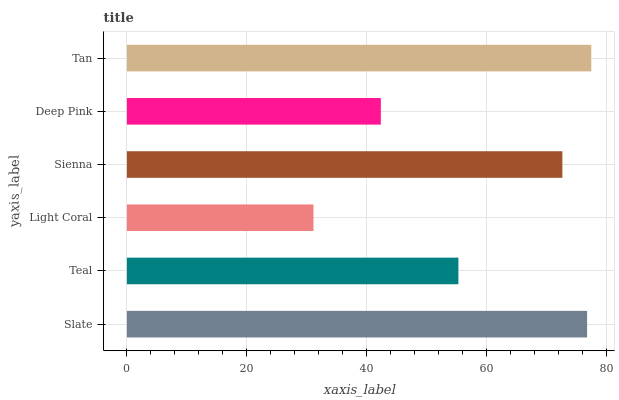Is Light Coral the minimum?
Answer yes or no. Yes. Is Tan the maximum?
Answer yes or no. Yes. Is Teal the minimum?
Answer yes or no. No. Is Teal the maximum?
Answer yes or no. No. Is Slate greater than Teal?
Answer yes or no. Yes. Is Teal less than Slate?
Answer yes or no. Yes. Is Teal greater than Slate?
Answer yes or no. No. Is Slate less than Teal?
Answer yes or no. No. Is Sienna the high median?
Answer yes or no. Yes. Is Teal the low median?
Answer yes or no. Yes. Is Deep Pink the high median?
Answer yes or no. No. Is Deep Pink the low median?
Answer yes or no. No. 